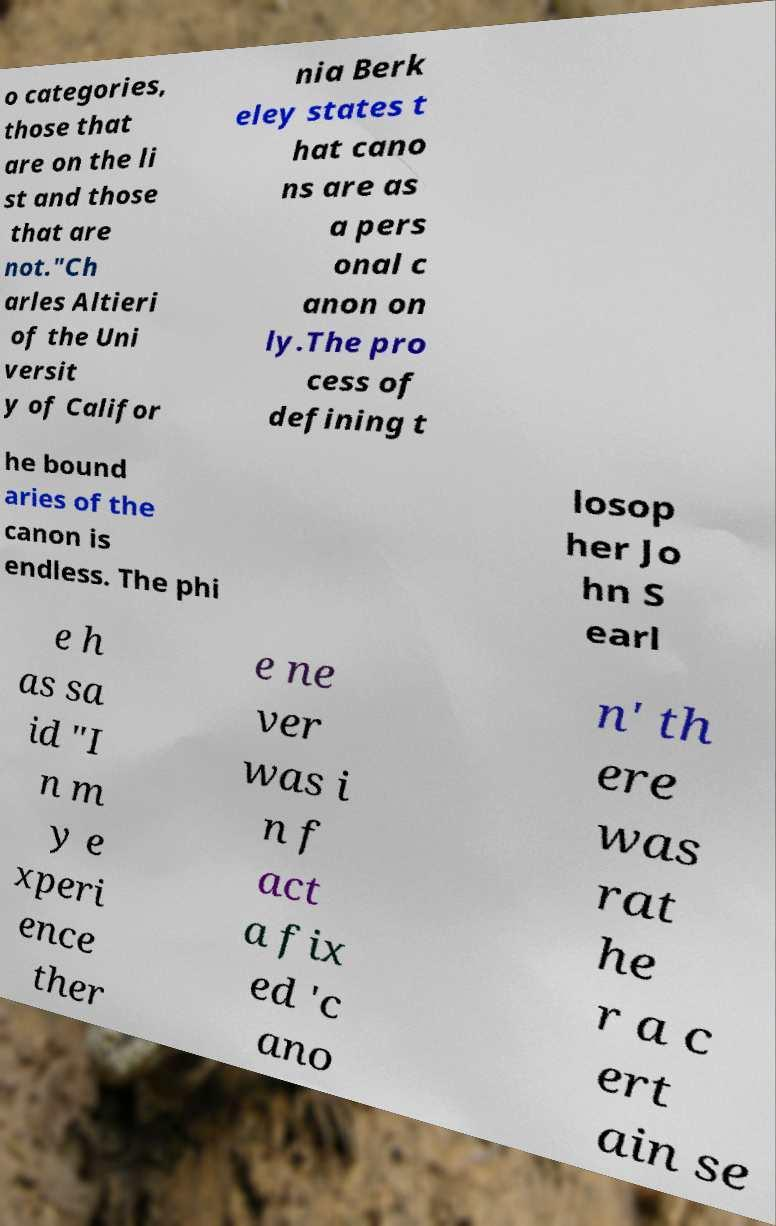I need the written content from this picture converted into text. Can you do that? o categories, those that are on the li st and those that are not."Ch arles Altieri of the Uni versit y of Califor nia Berk eley states t hat cano ns are as a pers onal c anon on ly.The pro cess of defining t he bound aries of the canon is endless. The phi losop her Jo hn S earl e h as sa id "I n m y e xperi ence ther e ne ver was i n f act a fix ed 'c ano n' th ere was rat he r a c ert ain se 